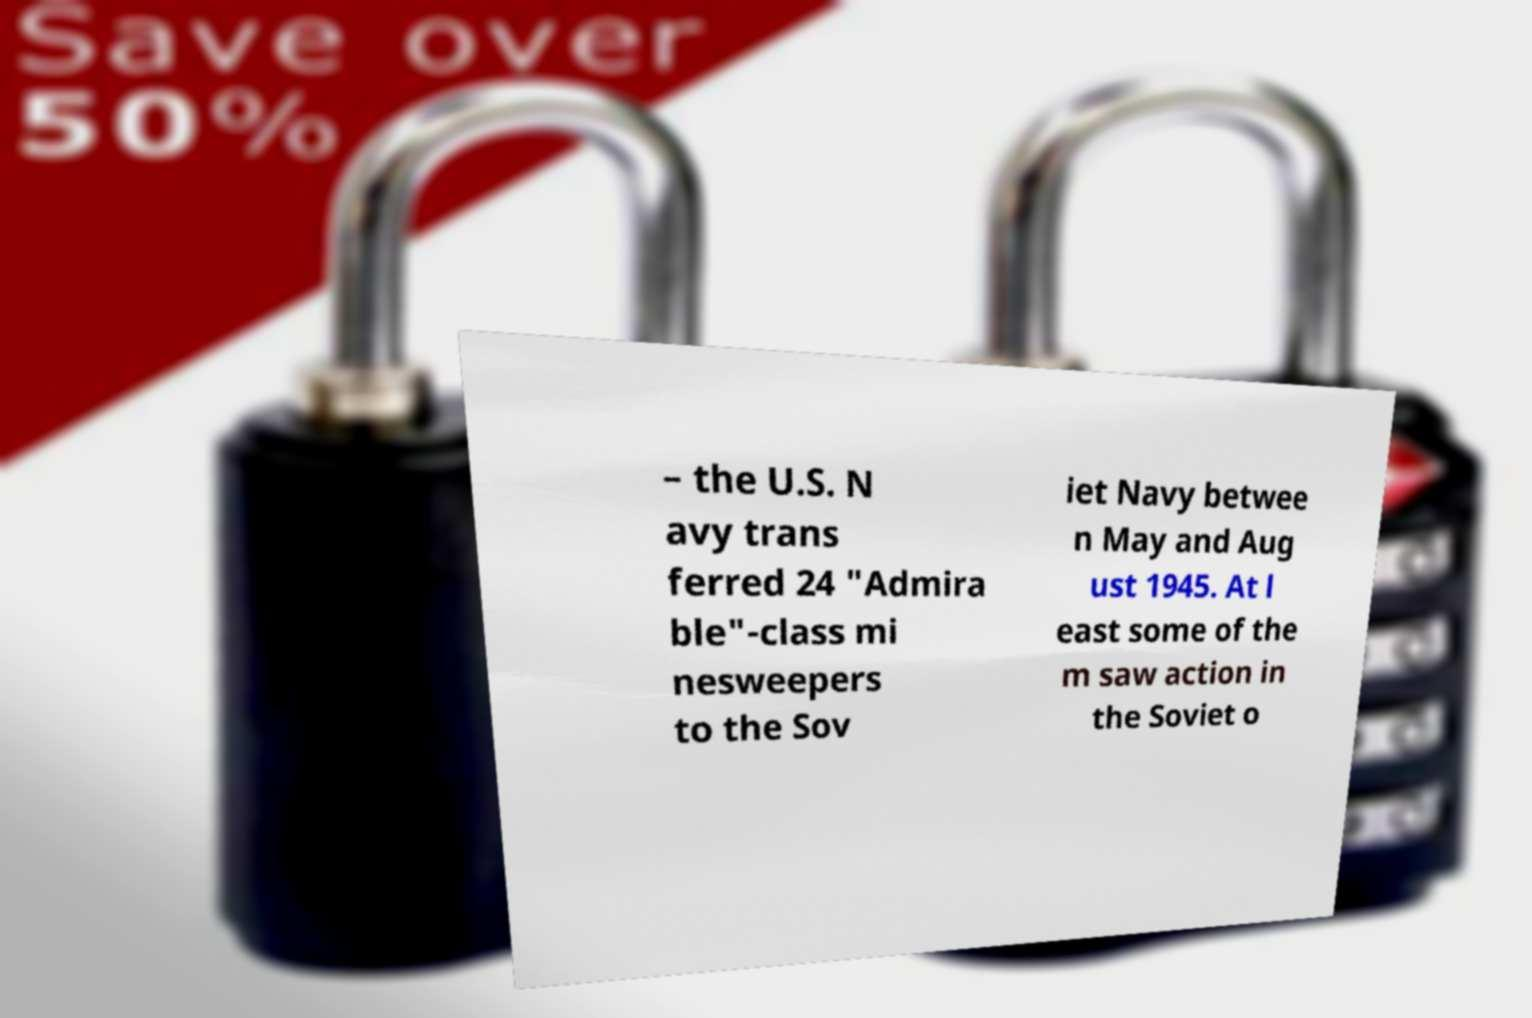Please read and relay the text visible in this image. What does it say? – the U.S. N avy trans ferred 24 "Admira ble"-class mi nesweepers to the Sov iet Navy betwee n May and Aug ust 1945. At l east some of the m saw action in the Soviet o 